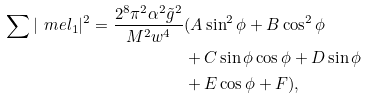Convert formula to latex. <formula><loc_0><loc_0><loc_500><loc_500>\sum | \ m e l _ { 1 } | ^ { 2 } = \frac { 2 ^ { 8 } \pi ^ { 2 } \alpha ^ { 2 } \tilde { g } ^ { 2 } } { M ^ { 2 } w ^ { 4 } } & ( A \sin ^ { 2 } \phi + B \cos ^ { 2 } \phi \\ & + C \sin \phi \cos \phi + D \sin \phi \\ & + E \cos \phi + F ) ,</formula> 